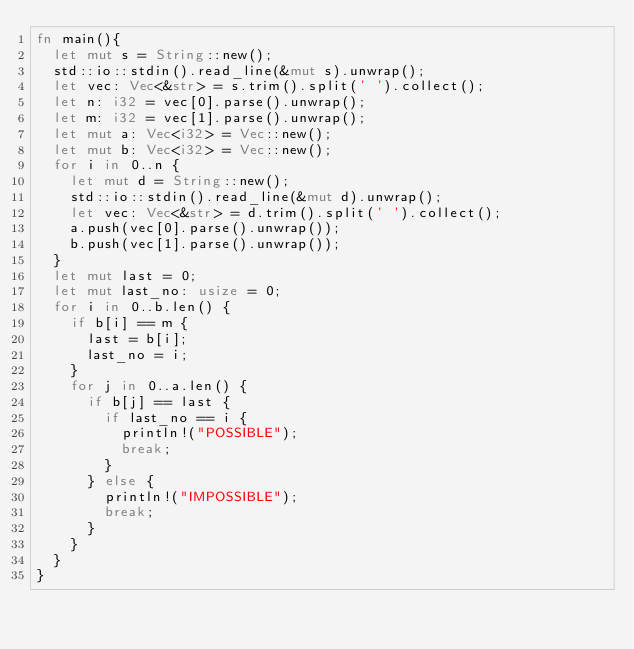Convert code to text. <code><loc_0><loc_0><loc_500><loc_500><_Rust_>fn main(){
	let mut s = String::new();
	std::io::stdin().read_line(&mut s).unwrap();
	let vec: Vec<&str> = s.trim().split(' ').collect();
	let n: i32 = vec[0].parse().unwrap();
	let m: i32 = vec[1].parse().unwrap();
	let mut a: Vec<i32> = Vec::new();
	let mut b: Vec<i32> = Vec::new();
	for i in 0..n {
		let mut d = String::new();
		std::io::stdin().read_line(&mut d).unwrap();
		let vec: Vec<&str> = d.trim().split(' ').collect();
		a.push(vec[0].parse().unwrap());
		b.push(vec[1].parse().unwrap());
	}
	let mut last = 0;
	let mut last_no: usize = 0;
	for i in 0..b.len() {
		if b[i] == m {
			last = b[i];
			last_no = i;
		}
		for j in 0..a.len() {
			if b[j] == last {
				if last_no == i {
					println!("POSSIBLE");
					break;
				}
			} else {
				println!("IMPOSSIBLE");
				break;
			}
		}
	}
}
</code> 